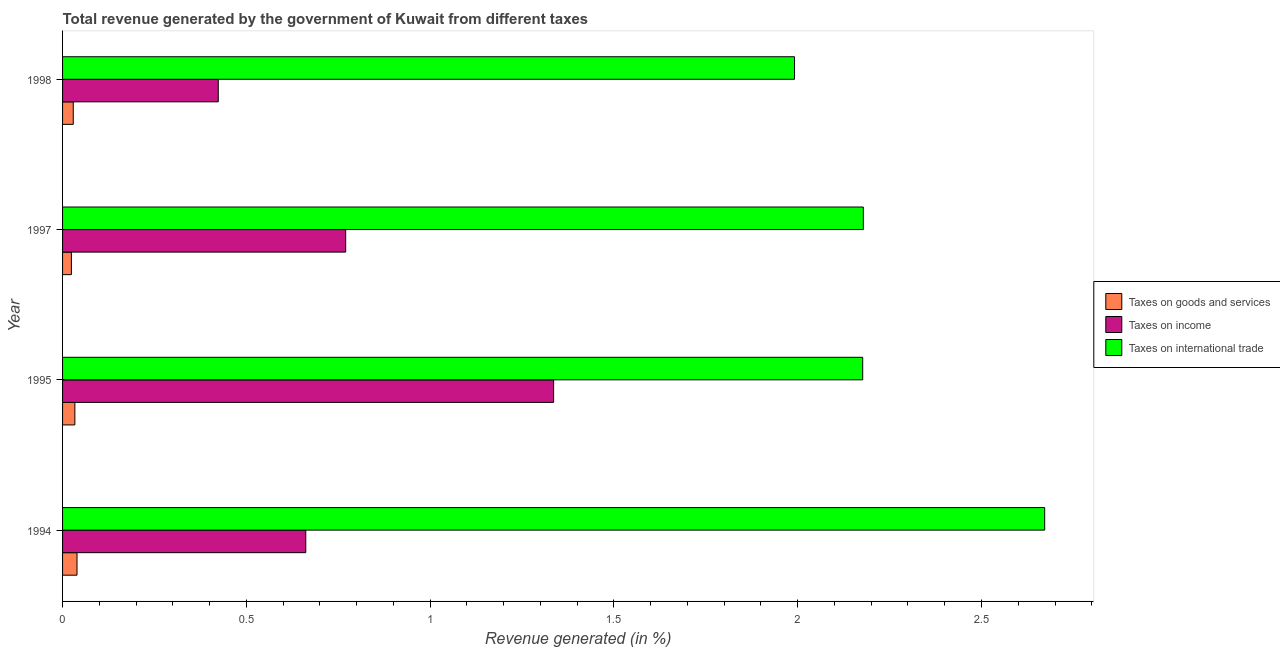Are the number of bars per tick equal to the number of legend labels?
Your answer should be very brief. Yes. How many bars are there on the 3rd tick from the bottom?
Keep it short and to the point. 3. What is the percentage of revenue generated by taxes on income in 1994?
Provide a succinct answer. 0.66. Across all years, what is the maximum percentage of revenue generated by tax on international trade?
Give a very brief answer. 2.67. Across all years, what is the minimum percentage of revenue generated by tax on international trade?
Make the answer very short. 1.99. In which year was the percentage of revenue generated by taxes on income maximum?
Make the answer very short. 1995. In which year was the percentage of revenue generated by taxes on goods and services minimum?
Keep it short and to the point. 1997. What is the total percentage of revenue generated by taxes on goods and services in the graph?
Ensure brevity in your answer.  0.13. What is the difference between the percentage of revenue generated by taxes on income in 1994 and that in 1997?
Your answer should be compact. -0.11. What is the difference between the percentage of revenue generated by taxes on income in 1997 and the percentage of revenue generated by tax on international trade in 1995?
Your response must be concise. -1.41. What is the average percentage of revenue generated by taxes on goods and services per year?
Offer a very short reply. 0.03. In the year 1997, what is the difference between the percentage of revenue generated by taxes on goods and services and percentage of revenue generated by tax on international trade?
Provide a succinct answer. -2.15. In how many years, is the percentage of revenue generated by taxes on income greater than 1.6 %?
Offer a terse response. 0. What is the ratio of the percentage of revenue generated by taxes on income in 1994 to that in 1995?
Keep it short and to the point. 0.49. Is the percentage of revenue generated by taxes on income in 1997 less than that in 1998?
Keep it short and to the point. No. Is the difference between the percentage of revenue generated by taxes on income in 1995 and 1997 greater than the difference between the percentage of revenue generated by taxes on goods and services in 1995 and 1997?
Offer a terse response. Yes. What is the difference between the highest and the second highest percentage of revenue generated by taxes on income?
Your response must be concise. 0.57. What is the difference between the highest and the lowest percentage of revenue generated by tax on international trade?
Provide a succinct answer. 0.68. In how many years, is the percentage of revenue generated by taxes on income greater than the average percentage of revenue generated by taxes on income taken over all years?
Give a very brief answer. 1. Is the sum of the percentage of revenue generated by taxes on goods and services in 1997 and 1998 greater than the maximum percentage of revenue generated by taxes on income across all years?
Offer a very short reply. No. What does the 3rd bar from the top in 1995 represents?
Offer a very short reply. Taxes on goods and services. What does the 3rd bar from the bottom in 1995 represents?
Provide a short and direct response. Taxes on international trade. Are all the bars in the graph horizontal?
Give a very brief answer. Yes. Are the values on the major ticks of X-axis written in scientific E-notation?
Ensure brevity in your answer.  No. How are the legend labels stacked?
Give a very brief answer. Vertical. What is the title of the graph?
Provide a short and direct response. Total revenue generated by the government of Kuwait from different taxes. What is the label or title of the X-axis?
Ensure brevity in your answer.  Revenue generated (in %). What is the Revenue generated (in %) in Taxes on goods and services in 1994?
Provide a succinct answer. 0.04. What is the Revenue generated (in %) of Taxes on income in 1994?
Provide a short and direct response. 0.66. What is the Revenue generated (in %) of Taxes on international trade in 1994?
Offer a terse response. 2.67. What is the Revenue generated (in %) in Taxes on goods and services in 1995?
Your answer should be compact. 0.03. What is the Revenue generated (in %) of Taxes on income in 1995?
Keep it short and to the point. 1.34. What is the Revenue generated (in %) of Taxes on international trade in 1995?
Offer a very short reply. 2.18. What is the Revenue generated (in %) of Taxes on goods and services in 1997?
Offer a very short reply. 0.02. What is the Revenue generated (in %) of Taxes on income in 1997?
Offer a terse response. 0.77. What is the Revenue generated (in %) of Taxes on international trade in 1997?
Your response must be concise. 2.18. What is the Revenue generated (in %) of Taxes on goods and services in 1998?
Your answer should be very brief. 0.03. What is the Revenue generated (in %) in Taxes on income in 1998?
Provide a short and direct response. 0.42. What is the Revenue generated (in %) of Taxes on international trade in 1998?
Your answer should be compact. 1.99. Across all years, what is the maximum Revenue generated (in %) of Taxes on goods and services?
Your response must be concise. 0.04. Across all years, what is the maximum Revenue generated (in %) in Taxes on income?
Ensure brevity in your answer.  1.34. Across all years, what is the maximum Revenue generated (in %) in Taxes on international trade?
Your answer should be compact. 2.67. Across all years, what is the minimum Revenue generated (in %) of Taxes on goods and services?
Offer a very short reply. 0.02. Across all years, what is the minimum Revenue generated (in %) in Taxes on income?
Your response must be concise. 0.42. Across all years, what is the minimum Revenue generated (in %) of Taxes on international trade?
Your response must be concise. 1.99. What is the total Revenue generated (in %) in Taxes on goods and services in the graph?
Offer a terse response. 0.13. What is the total Revenue generated (in %) in Taxes on income in the graph?
Keep it short and to the point. 3.19. What is the total Revenue generated (in %) of Taxes on international trade in the graph?
Your answer should be compact. 9.02. What is the difference between the Revenue generated (in %) of Taxes on goods and services in 1994 and that in 1995?
Provide a succinct answer. 0.01. What is the difference between the Revenue generated (in %) in Taxes on income in 1994 and that in 1995?
Give a very brief answer. -0.67. What is the difference between the Revenue generated (in %) in Taxes on international trade in 1994 and that in 1995?
Give a very brief answer. 0.5. What is the difference between the Revenue generated (in %) in Taxes on goods and services in 1994 and that in 1997?
Offer a terse response. 0.02. What is the difference between the Revenue generated (in %) of Taxes on income in 1994 and that in 1997?
Make the answer very short. -0.11. What is the difference between the Revenue generated (in %) in Taxes on international trade in 1994 and that in 1997?
Keep it short and to the point. 0.49. What is the difference between the Revenue generated (in %) of Taxes on goods and services in 1994 and that in 1998?
Your answer should be compact. 0.01. What is the difference between the Revenue generated (in %) of Taxes on income in 1994 and that in 1998?
Provide a succinct answer. 0.24. What is the difference between the Revenue generated (in %) of Taxes on international trade in 1994 and that in 1998?
Provide a short and direct response. 0.68. What is the difference between the Revenue generated (in %) of Taxes on goods and services in 1995 and that in 1997?
Your answer should be compact. 0.01. What is the difference between the Revenue generated (in %) of Taxes on income in 1995 and that in 1997?
Your response must be concise. 0.57. What is the difference between the Revenue generated (in %) in Taxes on international trade in 1995 and that in 1997?
Offer a terse response. -0. What is the difference between the Revenue generated (in %) in Taxes on goods and services in 1995 and that in 1998?
Provide a succinct answer. 0. What is the difference between the Revenue generated (in %) in Taxes on income in 1995 and that in 1998?
Give a very brief answer. 0.91. What is the difference between the Revenue generated (in %) of Taxes on international trade in 1995 and that in 1998?
Your response must be concise. 0.19. What is the difference between the Revenue generated (in %) in Taxes on goods and services in 1997 and that in 1998?
Provide a succinct answer. -0.01. What is the difference between the Revenue generated (in %) in Taxes on income in 1997 and that in 1998?
Give a very brief answer. 0.35. What is the difference between the Revenue generated (in %) in Taxes on international trade in 1997 and that in 1998?
Offer a terse response. 0.19. What is the difference between the Revenue generated (in %) of Taxes on goods and services in 1994 and the Revenue generated (in %) of Taxes on income in 1995?
Ensure brevity in your answer.  -1.3. What is the difference between the Revenue generated (in %) of Taxes on goods and services in 1994 and the Revenue generated (in %) of Taxes on international trade in 1995?
Your answer should be very brief. -2.14. What is the difference between the Revenue generated (in %) of Taxes on income in 1994 and the Revenue generated (in %) of Taxes on international trade in 1995?
Your response must be concise. -1.52. What is the difference between the Revenue generated (in %) of Taxes on goods and services in 1994 and the Revenue generated (in %) of Taxes on income in 1997?
Keep it short and to the point. -0.73. What is the difference between the Revenue generated (in %) of Taxes on goods and services in 1994 and the Revenue generated (in %) of Taxes on international trade in 1997?
Make the answer very short. -2.14. What is the difference between the Revenue generated (in %) in Taxes on income in 1994 and the Revenue generated (in %) in Taxes on international trade in 1997?
Offer a terse response. -1.52. What is the difference between the Revenue generated (in %) of Taxes on goods and services in 1994 and the Revenue generated (in %) of Taxes on income in 1998?
Provide a succinct answer. -0.38. What is the difference between the Revenue generated (in %) of Taxes on goods and services in 1994 and the Revenue generated (in %) of Taxes on international trade in 1998?
Offer a terse response. -1.95. What is the difference between the Revenue generated (in %) in Taxes on income in 1994 and the Revenue generated (in %) in Taxes on international trade in 1998?
Offer a very short reply. -1.33. What is the difference between the Revenue generated (in %) in Taxes on goods and services in 1995 and the Revenue generated (in %) in Taxes on income in 1997?
Your response must be concise. -0.74. What is the difference between the Revenue generated (in %) of Taxes on goods and services in 1995 and the Revenue generated (in %) of Taxes on international trade in 1997?
Ensure brevity in your answer.  -2.15. What is the difference between the Revenue generated (in %) in Taxes on income in 1995 and the Revenue generated (in %) in Taxes on international trade in 1997?
Ensure brevity in your answer.  -0.84. What is the difference between the Revenue generated (in %) of Taxes on goods and services in 1995 and the Revenue generated (in %) of Taxes on income in 1998?
Your answer should be compact. -0.39. What is the difference between the Revenue generated (in %) of Taxes on goods and services in 1995 and the Revenue generated (in %) of Taxes on international trade in 1998?
Provide a succinct answer. -1.96. What is the difference between the Revenue generated (in %) of Taxes on income in 1995 and the Revenue generated (in %) of Taxes on international trade in 1998?
Your answer should be compact. -0.66. What is the difference between the Revenue generated (in %) of Taxes on goods and services in 1997 and the Revenue generated (in %) of Taxes on income in 1998?
Offer a terse response. -0.4. What is the difference between the Revenue generated (in %) in Taxes on goods and services in 1997 and the Revenue generated (in %) in Taxes on international trade in 1998?
Provide a succinct answer. -1.97. What is the difference between the Revenue generated (in %) of Taxes on income in 1997 and the Revenue generated (in %) of Taxes on international trade in 1998?
Your answer should be very brief. -1.22. What is the average Revenue generated (in %) in Taxes on goods and services per year?
Give a very brief answer. 0.03. What is the average Revenue generated (in %) in Taxes on income per year?
Make the answer very short. 0.8. What is the average Revenue generated (in %) in Taxes on international trade per year?
Your answer should be very brief. 2.25. In the year 1994, what is the difference between the Revenue generated (in %) of Taxes on goods and services and Revenue generated (in %) of Taxes on income?
Your response must be concise. -0.62. In the year 1994, what is the difference between the Revenue generated (in %) in Taxes on goods and services and Revenue generated (in %) in Taxes on international trade?
Keep it short and to the point. -2.63. In the year 1994, what is the difference between the Revenue generated (in %) in Taxes on income and Revenue generated (in %) in Taxes on international trade?
Ensure brevity in your answer.  -2.01. In the year 1995, what is the difference between the Revenue generated (in %) of Taxes on goods and services and Revenue generated (in %) of Taxes on income?
Keep it short and to the point. -1.3. In the year 1995, what is the difference between the Revenue generated (in %) in Taxes on goods and services and Revenue generated (in %) in Taxes on international trade?
Provide a succinct answer. -2.14. In the year 1995, what is the difference between the Revenue generated (in %) in Taxes on income and Revenue generated (in %) in Taxes on international trade?
Your answer should be compact. -0.84. In the year 1997, what is the difference between the Revenue generated (in %) of Taxes on goods and services and Revenue generated (in %) of Taxes on income?
Keep it short and to the point. -0.75. In the year 1997, what is the difference between the Revenue generated (in %) of Taxes on goods and services and Revenue generated (in %) of Taxes on international trade?
Offer a terse response. -2.15. In the year 1997, what is the difference between the Revenue generated (in %) in Taxes on income and Revenue generated (in %) in Taxes on international trade?
Keep it short and to the point. -1.41. In the year 1998, what is the difference between the Revenue generated (in %) in Taxes on goods and services and Revenue generated (in %) in Taxes on income?
Provide a succinct answer. -0.39. In the year 1998, what is the difference between the Revenue generated (in %) in Taxes on goods and services and Revenue generated (in %) in Taxes on international trade?
Keep it short and to the point. -1.96. In the year 1998, what is the difference between the Revenue generated (in %) in Taxes on income and Revenue generated (in %) in Taxes on international trade?
Make the answer very short. -1.57. What is the ratio of the Revenue generated (in %) of Taxes on goods and services in 1994 to that in 1995?
Keep it short and to the point. 1.17. What is the ratio of the Revenue generated (in %) of Taxes on income in 1994 to that in 1995?
Your response must be concise. 0.5. What is the ratio of the Revenue generated (in %) in Taxes on international trade in 1994 to that in 1995?
Provide a short and direct response. 1.23. What is the ratio of the Revenue generated (in %) of Taxes on goods and services in 1994 to that in 1997?
Offer a terse response. 1.64. What is the ratio of the Revenue generated (in %) of Taxes on income in 1994 to that in 1997?
Your answer should be compact. 0.86. What is the ratio of the Revenue generated (in %) in Taxes on international trade in 1994 to that in 1997?
Provide a short and direct response. 1.23. What is the ratio of the Revenue generated (in %) in Taxes on goods and services in 1994 to that in 1998?
Your answer should be very brief. 1.35. What is the ratio of the Revenue generated (in %) in Taxes on income in 1994 to that in 1998?
Make the answer very short. 1.56. What is the ratio of the Revenue generated (in %) in Taxes on international trade in 1994 to that in 1998?
Provide a short and direct response. 1.34. What is the ratio of the Revenue generated (in %) of Taxes on goods and services in 1995 to that in 1997?
Offer a very short reply. 1.4. What is the ratio of the Revenue generated (in %) of Taxes on income in 1995 to that in 1997?
Ensure brevity in your answer.  1.73. What is the ratio of the Revenue generated (in %) in Taxes on goods and services in 1995 to that in 1998?
Provide a short and direct response. 1.15. What is the ratio of the Revenue generated (in %) in Taxes on income in 1995 to that in 1998?
Ensure brevity in your answer.  3.15. What is the ratio of the Revenue generated (in %) of Taxes on international trade in 1995 to that in 1998?
Provide a short and direct response. 1.09. What is the ratio of the Revenue generated (in %) of Taxes on goods and services in 1997 to that in 1998?
Make the answer very short. 0.82. What is the ratio of the Revenue generated (in %) in Taxes on income in 1997 to that in 1998?
Provide a short and direct response. 1.82. What is the ratio of the Revenue generated (in %) in Taxes on international trade in 1997 to that in 1998?
Make the answer very short. 1.09. What is the difference between the highest and the second highest Revenue generated (in %) of Taxes on goods and services?
Offer a very short reply. 0.01. What is the difference between the highest and the second highest Revenue generated (in %) in Taxes on income?
Offer a very short reply. 0.57. What is the difference between the highest and the second highest Revenue generated (in %) of Taxes on international trade?
Your response must be concise. 0.49. What is the difference between the highest and the lowest Revenue generated (in %) of Taxes on goods and services?
Make the answer very short. 0.02. What is the difference between the highest and the lowest Revenue generated (in %) of Taxes on income?
Offer a very short reply. 0.91. What is the difference between the highest and the lowest Revenue generated (in %) in Taxes on international trade?
Offer a terse response. 0.68. 